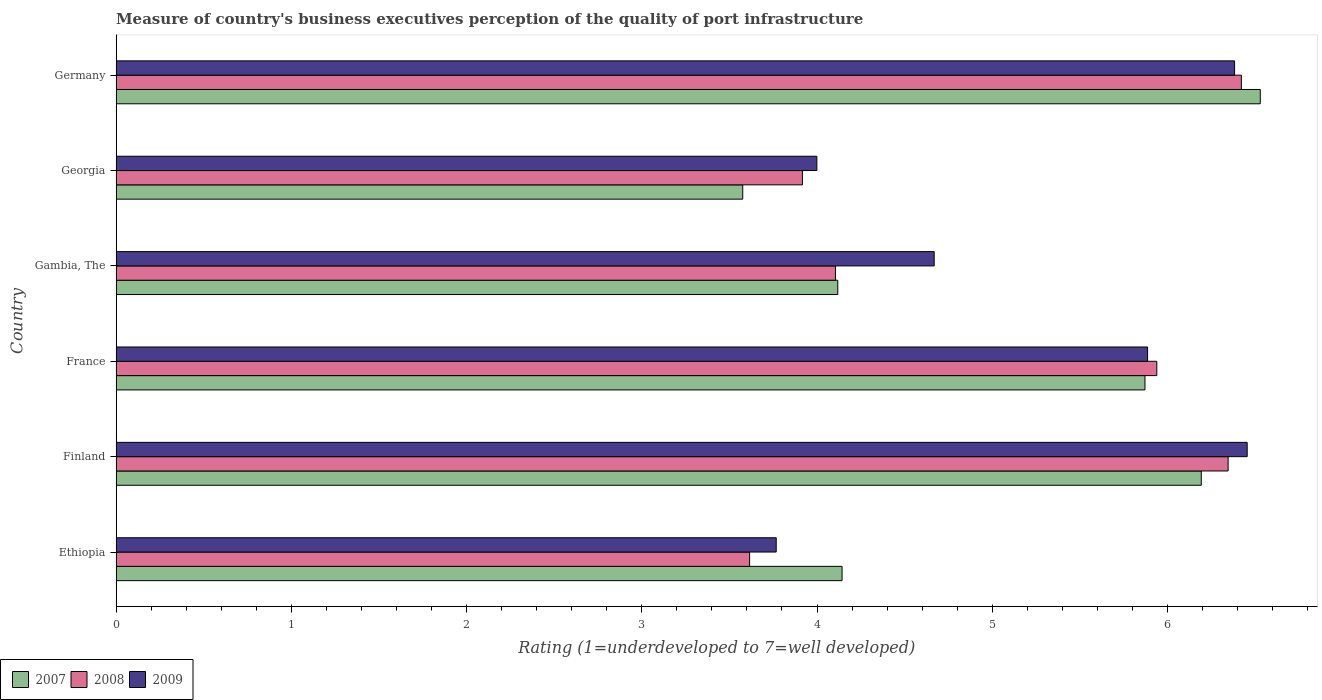How many different coloured bars are there?
Ensure brevity in your answer.  3. How many bars are there on the 4th tick from the bottom?
Your answer should be very brief. 3. What is the label of the 6th group of bars from the top?
Offer a terse response. Ethiopia. What is the ratings of the quality of port infrastructure in 2007 in Ethiopia?
Provide a succinct answer. 4.14. Across all countries, what is the maximum ratings of the quality of port infrastructure in 2009?
Make the answer very short. 6.45. Across all countries, what is the minimum ratings of the quality of port infrastructure in 2007?
Your response must be concise. 3.58. In which country was the ratings of the quality of port infrastructure in 2007 maximum?
Ensure brevity in your answer.  Germany. In which country was the ratings of the quality of port infrastructure in 2007 minimum?
Offer a very short reply. Georgia. What is the total ratings of the quality of port infrastructure in 2008 in the graph?
Your answer should be very brief. 30.34. What is the difference between the ratings of the quality of port infrastructure in 2009 in Finland and that in Gambia, The?
Provide a succinct answer. 1.79. What is the difference between the ratings of the quality of port infrastructure in 2008 in Ethiopia and the ratings of the quality of port infrastructure in 2007 in Georgia?
Your response must be concise. 0.04. What is the average ratings of the quality of port infrastructure in 2007 per country?
Your response must be concise. 5.07. What is the difference between the ratings of the quality of port infrastructure in 2009 and ratings of the quality of port infrastructure in 2007 in France?
Offer a terse response. 0.01. What is the ratio of the ratings of the quality of port infrastructure in 2008 in France to that in Georgia?
Your answer should be compact. 1.52. Is the ratings of the quality of port infrastructure in 2007 in Ethiopia less than that in Germany?
Provide a short and direct response. Yes. What is the difference between the highest and the second highest ratings of the quality of port infrastructure in 2008?
Ensure brevity in your answer.  0.08. What is the difference between the highest and the lowest ratings of the quality of port infrastructure in 2009?
Keep it short and to the point. 2.69. What does the 3rd bar from the top in Gambia, The represents?
Make the answer very short. 2007. Is it the case that in every country, the sum of the ratings of the quality of port infrastructure in 2007 and ratings of the quality of port infrastructure in 2008 is greater than the ratings of the quality of port infrastructure in 2009?
Your answer should be very brief. Yes. What is the difference between two consecutive major ticks on the X-axis?
Make the answer very short. 1. Where does the legend appear in the graph?
Provide a succinct answer. Bottom left. How many legend labels are there?
Make the answer very short. 3. How are the legend labels stacked?
Provide a short and direct response. Horizontal. What is the title of the graph?
Give a very brief answer. Measure of country's business executives perception of the quality of port infrastructure. What is the label or title of the X-axis?
Provide a short and direct response. Rating (1=underdeveloped to 7=well developed). What is the Rating (1=underdeveloped to 7=well developed) of 2007 in Ethiopia?
Your answer should be very brief. 4.14. What is the Rating (1=underdeveloped to 7=well developed) of 2008 in Ethiopia?
Offer a terse response. 3.62. What is the Rating (1=underdeveloped to 7=well developed) in 2009 in Ethiopia?
Provide a succinct answer. 3.77. What is the Rating (1=underdeveloped to 7=well developed) of 2007 in Finland?
Your response must be concise. 6.19. What is the Rating (1=underdeveloped to 7=well developed) of 2008 in Finland?
Provide a short and direct response. 6.35. What is the Rating (1=underdeveloped to 7=well developed) in 2009 in Finland?
Offer a terse response. 6.45. What is the Rating (1=underdeveloped to 7=well developed) of 2007 in France?
Make the answer very short. 5.87. What is the Rating (1=underdeveloped to 7=well developed) of 2008 in France?
Make the answer very short. 5.94. What is the Rating (1=underdeveloped to 7=well developed) of 2009 in France?
Your answer should be compact. 5.89. What is the Rating (1=underdeveloped to 7=well developed) of 2007 in Gambia, The?
Ensure brevity in your answer.  4.12. What is the Rating (1=underdeveloped to 7=well developed) of 2008 in Gambia, The?
Your answer should be very brief. 4.11. What is the Rating (1=underdeveloped to 7=well developed) of 2009 in Gambia, The?
Your answer should be very brief. 4.67. What is the Rating (1=underdeveloped to 7=well developed) in 2007 in Georgia?
Offer a terse response. 3.58. What is the Rating (1=underdeveloped to 7=well developed) in 2008 in Georgia?
Your answer should be very brief. 3.92. What is the Rating (1=underdeveloped to 7=well developed) in 2009 in Georgia?
Offer a very short reply. 4. What is the Rating (1=underdeveloped to 7=well developed) in 2007 in Germany?
Offer a very short reply. 6.53. What is the Rating (1=underdeveloped to 7=well developed) in 2008 in Germany?
Offer a very short reply. 6.42. What is the Rating (1=underdeveloped to 7=well developed) of 2009 in Germany?
Provide a succinct answer. 6.38. Across all countries, what is the maximum Rating (1=underdeveloped to 7=well developed) in 2007?
Make the answer very short. 6.53. Across all countries, what is the maximum Rating (1=underdeveloped to 7=well developed) of 2008?
Provide a succinct answer. 6.42. Across all countries, what is the maximum Rating (1=underdeveloped to 7=well developed) in 2009?
Keep it short and to the point. 6.45. Across all countries, what is the minimum Rating (1=underdeveloped to 7=well developed) in 2007?
Your answer should be very brief. 3.58. Across all countries, what is the minimum Rating (1=underdeveloped to 7=well developed) of 2008?
Offer a very short reply. 3.62. Across all countries, what is the minimum Rating (1=underdeveloped to 7=well developed) in 2009?
Your answer should be compact. 3.77. What is the total Rating (1=underdeveloped to 7=well developed) of 2007 in the graph?
Make the answer very short. 30.43. What is the total Rating (1=underdeveloped to 7=well developed) of 2008 in the graph?
Your answer should be compact. 30.34. What is the total Rating (1=underdeveloped to 7=well developed) in 2009 in the graph?
Provide a succinct answer. 31.16. What is the difference between the Rating (1=underdeveloped to 7=well developed) in 2007 in Ethiopia and that in Finland?
Make the answer very short. -2.05. What is the difference between the Rating (1=underdeveloped to 7=well developed) of 2008 in Ethiopia and that in Finland?
Your response must be concise. -2.73. What is the difference between the Rating (1=underdeveloped to 7=well developed) in 2009 in Ethiopia and that in Finland?
Your response must be concise. -2.69. What is the difference between the Rating (1=underdeveloped to 7=well developed) in 2007 in Ethiopia and that in France?
Keep it short and to the point. -1.73. What is the difference between the Rating (1=underdeveloped to 7=well developed) of 2008 in Ethiopia and that in France?
Offer a very short reply. -2.32. What is the difference between the Rating (1=underdeveloped to 7=well developed) of 2009 in Ethiopia and that in France?
Make the answer very short. -2.12. What is the difference between the Rating (1=underdeveloped to 7=well developed) of 2007 in Ethiopia and that in Gambia, The?
Your answer should be compact. 0.02. What is the difference between the Rating (1=underdeveloped to 7=well developed) of 2008 in Ethiopia and that in Gambia, The?
Make the answer very short. -0.49. What is the difference between the Rating (1=underdeveloped to 7=well developed) in 2009 in Ethiopia and that in Gambia, The?
Offer a terse response. -0.9. What is the difference between the Rating (1=underdeveloped to 7=well developed) in 2007 in Ethiopia and that in Georgia?
Offer a terse response. 0.57. What is the difference between the Rating (1=underdeveloped to 7=well developed) of 2008 in Ethiopia and that in Georgia?
Provide a succinct answer. -0.3. What is the difference between the Rating (1=underdeveloped to 7=well developed) in 2009 in Ethiopia and that in Georgia?
Give a very brief answer. -0.23. What is the difference between the Rating (1=underdeveloped to 7=well developed) in 2007 in Ethiopia and that in Germany?
Ensure brevity in your answer.  -2.39. What is the difference between the Rating (1=underdeveloped to 7=well developed) of 2008 in Ethiopia and that in Germany?
Offer a very short reply. -2.81. What is the difference between the Rating (1=underdeveloped to 7=well developed) of 2009 in Ethiopia and that in Germany?
Ensure brevity in your answer.  -2.62. What is the difference between the Rating (1=underdeveloped to 7=well developed) of 2007 in Finland and that in France?
Ensure brevity in your answer.  0.32. What is the difference between the Rating (1=underdeveloped to 7=well developed) in 2008 in Finland and that in France?
Ensure brevity in your answer.  0.41. What is the difference between the Rating (1=underdeveloped to 7=well developed) in 2009 in Finland and that in France?
Keep it short and to the point. 0.57. What is the difference between the Rating (1=underdeveloped to 7=well developed) of 2007 in Finland and that in Gambia, The?
Your answer should be very brief. 2.07. What is the difference between the Rating (1=underdeveloped to 7=well developed) in 2008 in Finland and that in Gambia, The?
Your response must be concise. 2.24. What is the difference between the Rating (1=underdeveloped to 7=well developed) of 2009 in Finland and that in Gambia, The?
Keep it short and to the point. 1.79. What is the difference between the Rating (1=underdeveloped to 7=well developed) in 2007 in Finland and that in Georgia?
Provide a succinct answer. 2.62. What is the difference between the Rating (1=underdeveloped to 7=well developed) in 2008 in Finland and that in Georgia?
Offer a very short reply. 2.43. What is the difference between the Rating (1=underdeveloped to 7=well developed) of 2009 in Finland and that in Georgia?
Offer a terse response. 2.46. What is the difference between the Rating (1=underdeveloped to 7=well developed) in 2007 in Finland and that in Germany?
Make the answer very short. -0.34. What is the difference between the Rating (1=underdeveloped to 7=well developed) of 2008 in Finland and that in Germany?
Give a very brief answer. -0.08. What is the difference between the Rating (1=underdeveloped to 7=well developed) of 2009 in Finland and that in Germany?
Offer a terse response. 0.07. What is the difference between the Rating (1=underdeveloped to 7=well developed) in 2007 in France and that in Gambia, The?
Your response must be concise. 1.75. What is the difference between the Rating (1=underdeveloped to 7=well developed) in 2008 in France and that in Gambia, The?
Make the answer very short. 1.83. What is the difference between the Rating (1=underdeveloped to 7=well developed) in 2009 in France and that in Gambia, The?
Your answer should be compact. 1.22. What is the difference between the Rating (1=underdeveloped to 7=well developed) in 2007 in France and that in Georgia?
Provide a succinct answer. 2.3. What is the difference between the Rating (1=underdeveloped to 7=well developed) of 2008 in France and that in Georgia?
Offer a very short reply. 2.02. What is the difference between the Rating (1=underdeveloped to 7=well developed) in 2009 in France and that in Georgia?
Provide a succinct answer. 1.89. What is the difference between the Rating (1=underdeveloped to 7=well developed) in 2007 in France and that in Germany?
Your answer should be compact. -0.66. What is the difference between the Rating (1=underdeveloped to 7=well developed) in 2008 in France and that in Germany?
Your answer should be very brief. -0.48. What is the difference between the Rating (1=underdeveloped to 7=well developed) of 2009 in France and that in Germany?
Give a very brief answer. -0.5. What is the difference between the Rating (1=underdeveloped to 7=well developed) in 2007 in Gambia, The and that in Georgia?
Make the answer very short. 0.54. What is the difference between the Rating (1=underdeveloped to 7=well developed) of 2008 in Gambia, The and that in Georgia?
Offer a very short reply. 0.19. What is the difference between the Rating (1=underdeveloped to 7=well developed) in 2009 in Gambia, The and that in Georgia?
Your response must be concise. 0.67. What is the difference between the Rating (1=underdeveloped to 7=well developed) in 2007 in Gambia, The and that in Germany?
Offer a terse response. -2.41. What is the difference between the Rating (1=underdeveloped to 7=well developed) of 2008 in Gambia, The and that in Germany?
Your response must be concise. -2.32. What is the difference between the Rating (1=underdeveloped to 7=well developed) in 2009 in Gambia, The and that in Germany?
Your answer should be very brief. -1.71. What is the difference between the Rating (1=underdeveloped to 7=well developed) in 2007 in Georgia and that in Germany?
Your answer should be compact. -2.95. What is the difference between the Rating (1=underdeveloped to 7=well developed) in 2008 in Georgia and that in Germany?
Keep it short and to the point. -2.5. What is the difference between the Rating (1=underdeveloped to 7=well developed) in 2009 in Georgia and that in Germany?
Your answer should be very brief. -2.38. What is the difference between the Rating (1=underdeveloped to 7=well developed) of 2007 in Ethiopia and the Rating (1=underdeveloped to 7=well developed) of 2008 in Finland?
Provide a short and direct response. -2.2. What is the difference between the Rating (1=underdeveloped to 7=well developed) of 2007 in Ethiopia and the Rating (1=underdeveloped to 7=well developed) of 2009 in Finland?
Your answer should be very brief. -2.31. What is the difference between the Rating (1=underdeveloped to 7=well developed) of 2008 in Ethiopia and the Rating (1=underdeveloped to 7=well developed) of 2009 in Finland?
Your response must be concise. -2.84. What is the difference between the Rating (1=underdeveloped to 7=well developed) of 2007 in Ethiopia and the Rating (1=underdeveloped to 7=well developed) of 2008 in France?
Keep it short and to the point. -1.8. What is the difference between the Rating (1=underdeveloped to 7=well developed) of 2007 in Ethiopia and the Rating (1=underdeveloped to 7=well developed) of 2009 in France?
Ensure brevity in your answer.  -1.74. What is the difference between the Rating (1=underdeveloped to 7=well developed) in 2008 in Ethiopia and the Rating (1=underdeveloped to 7=well developed) in 2009 in France?
Provide a short and direct response. -2.27. What is the difference between the Rating (1=underdeveloped to 7=well developed) of 2007 in Ethiopia and the Rating (1=underdeveloped to 7=well developed) of 2008 in Gambia, The?
Provide a short and direct response. 0.04. What is the difference between the Rating (1=underdeveloped to 7=well developed) in 2007 in Ethiopia and the Rating (1=underdeveloped to 7=well developed) in 2009 in Gambia, The?
Keep it short and to the point. -0.53. What is the difference between the Rating (1=underdeveloped to 7=well developed) in 2008 in Ethiopia and the Rating (1=underdeveloped to 7=well developed) in 2009 in Gambia, The?
Provide a succinct answer. -1.05. What is the difference between the Rating (1=underdeveloped to 7=well developed) of 2007 in Ethiopia and the Rating (1=underdeveloped to 7=well developed) of 2008 in Georgia?
Ensure brevity in your answer.  0.23. What is the difference between the Rating (1=underdeveloped to 7=well developed) in 2007 in Ethiopia and the Rating (1=underdeveloped to 7=well developed) in 2009 in Georgia?
Offer a very short reply. 0.14. What is the difference between the Rating (1=underdeveloped to 7=well developed) in 2008 in Ethiopia and the Rating (1=underdeveloped to 7=well developed) in 2009 in Georgia?
Your answer should be very brief. -0.38. What is the difference between the Rating (1=underdeveloped to 7=well developed) in 2007 in Ethiopia and the Rating (1=underdeveloped to 7=well developed) in 2008 in Germany?
Ensure brevity in your answer.  -2.28. What is the difference between the Rating (1=underdeveloped to 7=well developed) of 2007 in Ethiopia and the Rating (1=underdeveloped to 7=well developed) of 2009 in Germany?
Make the answer very short. -2.24. What is the difference between the Rating (1=underdeveloped to 7=well developed) in 2008 in Ethiopia and the Rating (1=underdeveloped to 7=well developed) in 2009 in Germany?
Your answer should be compact. -2.77. What is the difference between the Rating (1=underdeveloped to 7=well developed) in 2007 in Finland and the Rating (1=underdeveloped to 7=well developed) in 2008 in France?
Offer a very short reply. 0.25. What is the difference between the Rating (1=underdeveloped to 7=well developed) of 2007 in Finland and the Rating (1=underdeveloped to 7=well developed) of 2009 in France?
Your response must be concise. 0.31. What is the difference between the Rating (1=underdeveloped to 7=well developed) of 2008 in Finland and the Rating (1=underdeveloped to 7=well developed) of 2009 in France?
Your response must be concise. 0.46. What is the difference between the Rating (1=underdeveloped to 7=well developed) in 2007 in Finland and the Rating (1=underdeveloped to 7=well developed) in 2008 in Gambia, The?
Your answer should be very brief. 2.09. What is the difference between the Rating (1=underdeveloped to 7=well developed) of 2007 in Finland and the Rating (1=underdeveloped to 7=well developed) of 2009 in Gambia, The?
Offer a terse response. 1.52. What is the difference between the Rating (1=underdeveloped to 7=well developed) in 2008 in Finland and the Rating (1=underdeveloped to 7=well developed) in 2009 in Gambia, The?
Your answer should be very brief. 1.68. What is the difference between the Rating (1=underdeveloped to 7=well developed) of 2007 in Finland and the Rating (1=underdeveloped to 7=well developed) of 2008 in Georgia?
Provide a succinct answer. 2.28. What is the difference between the Rating (1=underdeveloped to 7=well developed) in 2007 in Finland and the Rating (1=underdeveloped to 7=well developed) in 2009 in Georgia?
Offer a terse response. 2.19. What is the difference between the Rating (1=underdeveloped to 7=well developed) of 2008 in Finland and the Rating (1=underdeveloped to 7=well developed) of 2009 in Georgia?
Offer a terse response. 2.35. What is the difference between the Rating (1=underdeveloped to 7=well developed) of 2007 in Finland and the Rating (1=underdeveloped to 7=well developed) of 2008 in Germany?
Offer a terse response. -0.23. What is the difference between the Rating (1=underdeveloped to 7=well developed) of 2007 in Finland and the Rating (1=underdeveloped to 7=well developed) of 2009 in Germany?
Make the answer very short. -0.19. What is the difference between the Rating (1=underdeveloped to 7=well developed) of 2008 in Finland and the Rating (1=underdeveloped to 7=well developed) of 2009 in Germany?
Give a very brief answer. -0.04. What is the difference between the Rating (1=underdeveloped to 7=well developed) of 2007 in France and the Rating (1=underdeveloped to 7=well developed) of 2008 in Gambia, The?
Provide a short and direct response. 1.77. What is the difference between the Rating (1=underdeveloped to 7=well developed) in 2007 in France and the Rating (1=underdeveloped to 7=well developed) in 2009 in Gambia, The?
Offer a very short reply. 1.2. What is the difference between the Rating (1=underdeveloped to 7=well developed) in 2008 in France and the Rating (1=underdeveloped to 7=well developed) in 2009 in Gambia, The?
Offer a very short reply. 1.27. What is the difference between the Rating (1=underdeveloped to 7=well developed) of 2007 in France and the Rating (1=underdeveloped to 7=well developed) of 2008 in Georgia?
Keep it short and to the point. 1.95. What is the difference between the Rating (1=underdeveloped to 7=well developed) of 2007 in France and the Rating (1=underdeveloped to 7=well developed) of 2009 in Georgia?
Offer a very short reply. 1.87. What is the difference between the Rating (1=underdeveloped to 7=well developed) in 2008 in France and the Rating (1=underdeveloped to 7=well developed) in 2009 in Georgia?
Offer a terse response. 1.94. What is the difference between the Rating (1=underdeveloped to 7=well developed) in 2007 in France and the Rating (1=underdeveloped to 7=well developed) in 2008 in Germany?
Make the answer very short. -0.55. What is the difference between the Rating (1=underdeveloped to 7=well developed) in 2007 in France and the Rating (1=underdeveloped to 7=well developed) in 2009 in Germany?
Keep it short and to the point. -0.51. What is the difference between the Rating (1=underdeveloped to 7=well developed) of 2008 in France and the Rating (1=underdeveloped to 7=well developed) of 2009 in Germany?
Provide a succinct answer. -0.44. What is the difference between the Rating (1=underdeveloped to 7=well developed) of 2007 in Gambia, The and the Rating (1=underdeveloped to 7=well developed) of 2008 in Georgia?
Your answer should be very brief. 0.2. What is the difference between the Rating (1=underdeveloped to 7=well developed) of 2007 in Gambia, The and the Rating (1=underdeveloped to 7=well developed) of 2009 in Georgia?
Offer a very short reply. 0.12. What is the difference between the Rating (1=underdeveloped to 7=well developed) of 2008 in Gambia, The and the Rating (1=underdeveloped to 7=well developed) of 2009 in Georgia?
Make the answer very short. 0.11. What is the difference between the Rating (1=underdeveloped to 7=well developed) in 2007 in Gambia, The and the Rating (1=underdeveloped to 7=well developed) in 2008 in Germany?
Give a very brief answer. -2.3. What is the difference between the Rating (1=underdeveloped to 7=well developed) in 2007 in Gambia, The and the Rating (1=underdeveloped to 7=well developed) in 2009 in Germany?
Offer a very short reply. -2.26. What is the difference between the Rating (1=underdeveloped to 7=well developed) of 2008 in Gambia, The and the Rating (1=underdeveloped to 7=well developed) of 2009 in Germany?
Give a very brief answer. -2.28. What is the difference between the Rating (1=underdeveloped to 7=well developed) of 2007 in Georgia and the Rating (1=underdeveloped to 7=well developed) of 2008 in Germany?
Give a very brief answer. -2.85. What is the difference between the Rating (1=underdeveloped to 7=well developed) of 2007 in Georgia and the Rating (1=underdeveloped to 7=well developed) of 2009 in Germany?
Your answer should be very brief. -2.81. What is the difference between the Rating (1=underdeveloped to 7=well developed) of 2008 in Georgia and the Rating (1=underdeveloped to 7=well developed) of 2009 in Germany?
Your answer should be very brief. -2.47. What is the average Rating (1=underdeveloped to 7=well developed) in 2007 per country?
Offer a very short reply. 5.07. What is the average Rating (1=underdeveloped to 7=well developed) in 2008 per country?
Make the answer very short. 5.06. What is the average Rating (1=underdeveloped to 7=well developed) of 2009 per country?
Your response must be concise. 5.19. What is the difference between the Rating (1=underdeveloped to 7=well developed) of 2007 and Rating (1=underdeveloped to 7=well developed) of 2008 in Ethiopia?
Your answer should be very brief. 0.53. What is the difference between the Rating (1=underdeveloped to 7=well developed) of 2007 and Rating (1=underdeveloped to 7=well developed) of 2009 in Ethiopia?
Your response must be concise. 0.38. What is the difference between the Rating (1=underdeveloped to 7=well developed) of 2008 and Rating (1=underdeveloped to 7=well developed) of 2009 in Ethiopia?
Keep it short and to the point. -0.15. What is the difference between the Rating (1=underdeveloped to 7=well developed) in 2007 and Rating (1=underdeveloped to 7=well developed) in 2008 in Finland?
Ensure brevity in your answer.  -0.15. What is the difference between the Rating (1=underdeveloped to 7=well developed) in 2007 and Rating (1=underdeveloped to 7=well developed) in 2009 in Finland?
Your answer should be very brief. -0.26. What is the difference between the Rating (1=underdeveloped to 7=well developed) of 2008 and Rating (1=underdeveloped to 7=well developed) of 2009 in Finland?
Your response must be concise. -0.11. What is the difference between the Rating (1=underdeveloped to 7=well developed) of 2007 and Rating (1=underdeveloped to 7=well developed) of 2008 in France?
Your answer should be very brief. -0.07. What is the difference between the Rating (1=underdeveloped to 7=well developed) of 2007 and Rating (1=underdeveloped to 7=well developed) of 2009 in France?
Provide a short and direct response. -0.01. What is the difference between the Rating (1=underdeveloped to 7=well developed) in 2008 and Rating (1=underdeveloped to 7=well developed) in 2009 in France?
Provide a succinct answer. 0.05. What is the difference between the Rating (1=underdeveloped to 7=well developed) of 2007 and Rating (1=underdeveloped to 7=well developed) of 2008 in Gambia, The?
Your answer should be compact. 0.01. What is the difference between the Rating (1=underdeveloped to 7=well developed) in 2007 and Rating (1=underdeveloped to 7=well developed) in 2009 in Gambia, The?
Your answer should be very brief. -0.55. What is the difference between the Rating (1=underdeveloped to 7=well developed) in 2008 and Rating (1=underdeveloped to 7=well developed) in 2009 in Gambia, The?
Offer a terse response. -0.56. What is the difference between the Rating (1=underdeveloped to 7=well developed) of 2007 and Rating (1=underdeveloped to 7=well developed) of 2008 in Georgia?
Provide a short and direct response. -0.34. What is the difference between the Rating (1=underdeveloped to 7=well developed) in 2007 and Rating (1=underdeveloped to 7=well developed) in 2009 in Georgia?
Give a very brief answer. -0.42. What is the difference between the Rating (1=underdeveloped to 7=well developed) in 2008 and Rating (1=underdeveloped to 7=well developed) in 2009 in Georgia?
Ensure brevity in your answer.  -0.08. What is the difference between the Rating (1=underdeveloped to 7=well developed) of 2007 and Rating (1=underdeveloped to 7=well developed) of 2008 in Germany?
Your response must be concise. 0.11. What is the difference between the Rating (1=underdeveloped to 7=well developed) of 2007 and Rating (1=underdeveloped to 7=well developed) of 2009 in Germany?
Your answer should be compact. 0.15. What is the difference between the Rating (1=underdeveloped to 7=well developed) of 2008 and Rating (1=underdeveloped to 7=well developed) of 2009 in Germany?
Offer a terse response. 0.04. What is the ratio of the Rating (1=underdeveloped to 7=well developed) in 2007 in Ethiopia to that in Finland?
Offer a very short reply. 0.67. What is the ratio of the Rating (1=underdeveloped to 7=well developed) of 2008 in Ethiopia to that in Finland?
Your answer should be very brief. 0.57. What is the ratio of the Rating (1=underdeveloped to 7=well developed) of 2009 in Ethiopia to that in Finland?
Ensure brevity in your answer.  0.58. What is the ratio of the Rating (1=underdeveloped to 7=well developed) of 2007 in Ethiopia to that in France?
Your response must be concise. 0.71. What is the ratio of the Rating (1=underdeveloped to 7=well developed) in 2008 in Ethiopia to that in France?
Offer a terse response. 0.61. What is the ratio of the Rating (1=underdeveloped to 7=well developed) of 2009 in Ethiopia to that in France?
Your answer should be compact. 0.64. What is the ratio of the Rating (1=underdeveloped to 7=well developed) in 2008 in Ethiopia to that in Gambia, The?
Your response must be concise. 0.88. What is the ratio of the Rating (1=underdeveloped to 7=well developed) in 2009 in Ethiopia to that in Gambia, The?
Keep it short and to the point. 0.81. What is the ratio of the Rating (1=underdeveloped to 7=well developed) in 2007 in Ethiopia to that in Georgia?
Your answer should be very brief. 1.16. What is the ratio of the Rating (1=underdeveloped to 7=well developed) in 2008 in Ethiopia to that in Georgia?
Offer a very short reply. 0.92. What is the ratio of the Rating (1=underdeveloped to 7=well developed) of 2009 in Ethiopia to that in Georgia?
Ensure brevity in your answer.  0.94. What is the ratio of the Rating (1=underdeveloped to 7=well developed) in 2007 in Ethiopia to that in Germany?
Your answer should be compact. 0.63. What is the ratio of the Rating (1=underdeveloped to 7=well developed) of 2008 in Ethiopia to that in Germany?
Offer a terse response. 0.56. What is the ratio of the Rating (1=underdeveloped to 7=well developed) of 2009 in Ethiopia to that in Germany?
Offer a very short reply. 0.59. What is the ratio of the Rating (1=underdeveloped to 7=well developed) of 2007 in Finland to that in France?
Offer a very short reply. 1.05. What is the ratio of the Rating (1=underdeveloped to 7=well developed) in 2008 in Finland to that in France?
Keep it short and to the point. 1.07. What is the ratio of the Rating (1=underdeveloped to 7=well developed) of 2009 in Finland to that in France?
Make the answer very short. 1.1. What is the ratio of the Rating (1=underdeveloped to 7=well developed) of 2007 in Finland to that in Gambia, The?
Make the answer very short. 1.5. What is the ratio of the Rating (1=underdeveloped to 7=well developed) in 2008 in Finland to that in Gambia, The?
Provide a succinct answer. 1.55. What is the ratio of the Rating (1=underdeveloped to 7=well developed) in 2009 in Finland to that in Gambia, The?
Make the answer very short. 1.38. What is the ratio of the Rating (1=underdeveloped to 7=well developed) of 2007 in Finland to that in Georgia?
Make the answer very short. 1.73. What is the ratio of the Rating (1=underdeveloped to 7=well developed) of 2008 in Finland to that in Georgia?
Offer a very short reply. 1.62. What is the ratio of the Rating (1=underdeveloped to 7=well developed) of 2009 in Finland to that in Georgia?
Provide a succinct answer. 1.61. What is the ratio of the Rating (1=underdeveloped to 7=well developed) of 2007 in Finland to that in Germany?
Offer a terse response. 0.95. What is the ratio of the Rating (1=underdeveloped to 7=well developed) of 2008 in Finland to that in Germany?
Keep it short and to the point. 0.99. What is the ratio of the Rating (1=underdeveloped to 7=well developed) of 2009 in Finland to that in Germany?
Offer a very short reply. 1.01. What is the ratio of the Rating (1=underdeveloped to 7=well developed) in 2007 in France to that in Gambia, The?
Your answer should be compact. 1.43. What is the ratio of the Rating (1=underdeveloped to 7=well developed) of 2008 in France to that in Gambia, The?
Your answer should be compact. 1.45. What is the ratio of the Rating (1=underdeveloped to 7=well developed) of 2009 in France to that in Gambia, The?
Make the answer very short. 1.26. What is the ratio of the Rating (1=underdeveloped to 7=well developed) of 2007 in France to that in Georgia?
Your answer should be compact. 1.64. What is the ratio of the Rating (1=underdeveloped to 7=well developed) of 2008 in France to that in Georgia?
Your answer should be compact. 1.52. What is the ratio of the Rating (1=underdeveloped to 7=well developed) in 2009 in France to that in Georgia?
Your response must be concise. 1.47. What is the ratio of the Rating (1=underdeveloped to 7=well developed) of 2007 in France to that in Germany?
Give a very brief answer. 0.9. What is the ratio of the Rating (1=underdeveloped to 7=well developed) of 2008 in France to that in Germany?
Give a very brief answer. 0.92. What is the ratio of the Rating (1=underdeveloped to 7=well developed) of 2009 in France to that in Germany?
Make the answer very short. 0.92. What is the ratio of the Rating (1=underdeveloped to 7=well developed) of 2007 in Gambia, The to that in Georgia?
Provide a succinct answer. 1.15. What is the ratio of the Rating (1=underdeveloped to 7=well developed) in 2008 in Gambia, The to that in Georgia?
Provide a short and direct response. 1.05. What is the ratio of the Rating (1=underdeveloped to 7=well developed) of 2009 in Gambia, The to that in Georgia?
Make the answer very short. 1.17. What is the ratio of the Rating (1=underdeveloped to 7=well developed) in 2007 in Gambia, The to that in Germany?
Provide a short and direct response. 0.63. What is the ratio of the Rating (1=underdeveloped to 7=well developed) in 2008 in Gambia, The to that in Germany?
Give a very brief answer. 0.64. What is the ratio of the Rating (1=underdeveloped to 7=well developed) in 2009 in Gambia, The to that in Germany?
Your answer should be compact. 0.73. What is the ratio of the Rating (1=underdeveloped to 7=well developed) in 2007 in Georgia to that in Germany?
Give a very brief answer. 0.55. What is the ratio of the Rating (1=underdeveloped to 7=well developed) of 2008 in Georgia to that in Germany?
Offer a very short reply. 0.61. What is the ratio of the Rating (1=underdeveloped to 7=well developed) in 2009 in Georgia to that in Germany?
Ensure brevity in your answer.  0.63. What is the difference between the highest and the second highest Rating (1=underdeveloped to 7=well developed) in 2007?
Provide a short and direct response. 0.34. What is the difference between the highest and the second highest Rating (1=underdeveloped to 7=well developed) in 2008?
Offer a very short reply. 0.08. What is the difference between the highest and the second highest Rating (1=underdeveloped to 7=well developed) in 2009?
Give a very brief answer. 0.07. What is the difference between the highest and the lowest Rating (1=underdeveloped to 7=well developed) of 2007?
Your response must be concise. 2.95. What is the difference between the highest and the lowest Rating (1=underdeveloped to 7=well developed) of 2008?
Give a very brief answer. 2.81. What is the difference between the highest and the lowest Rating (1=underdeveloped to 7=well developed) in 2009?
Offer a terse response. 2.69. 